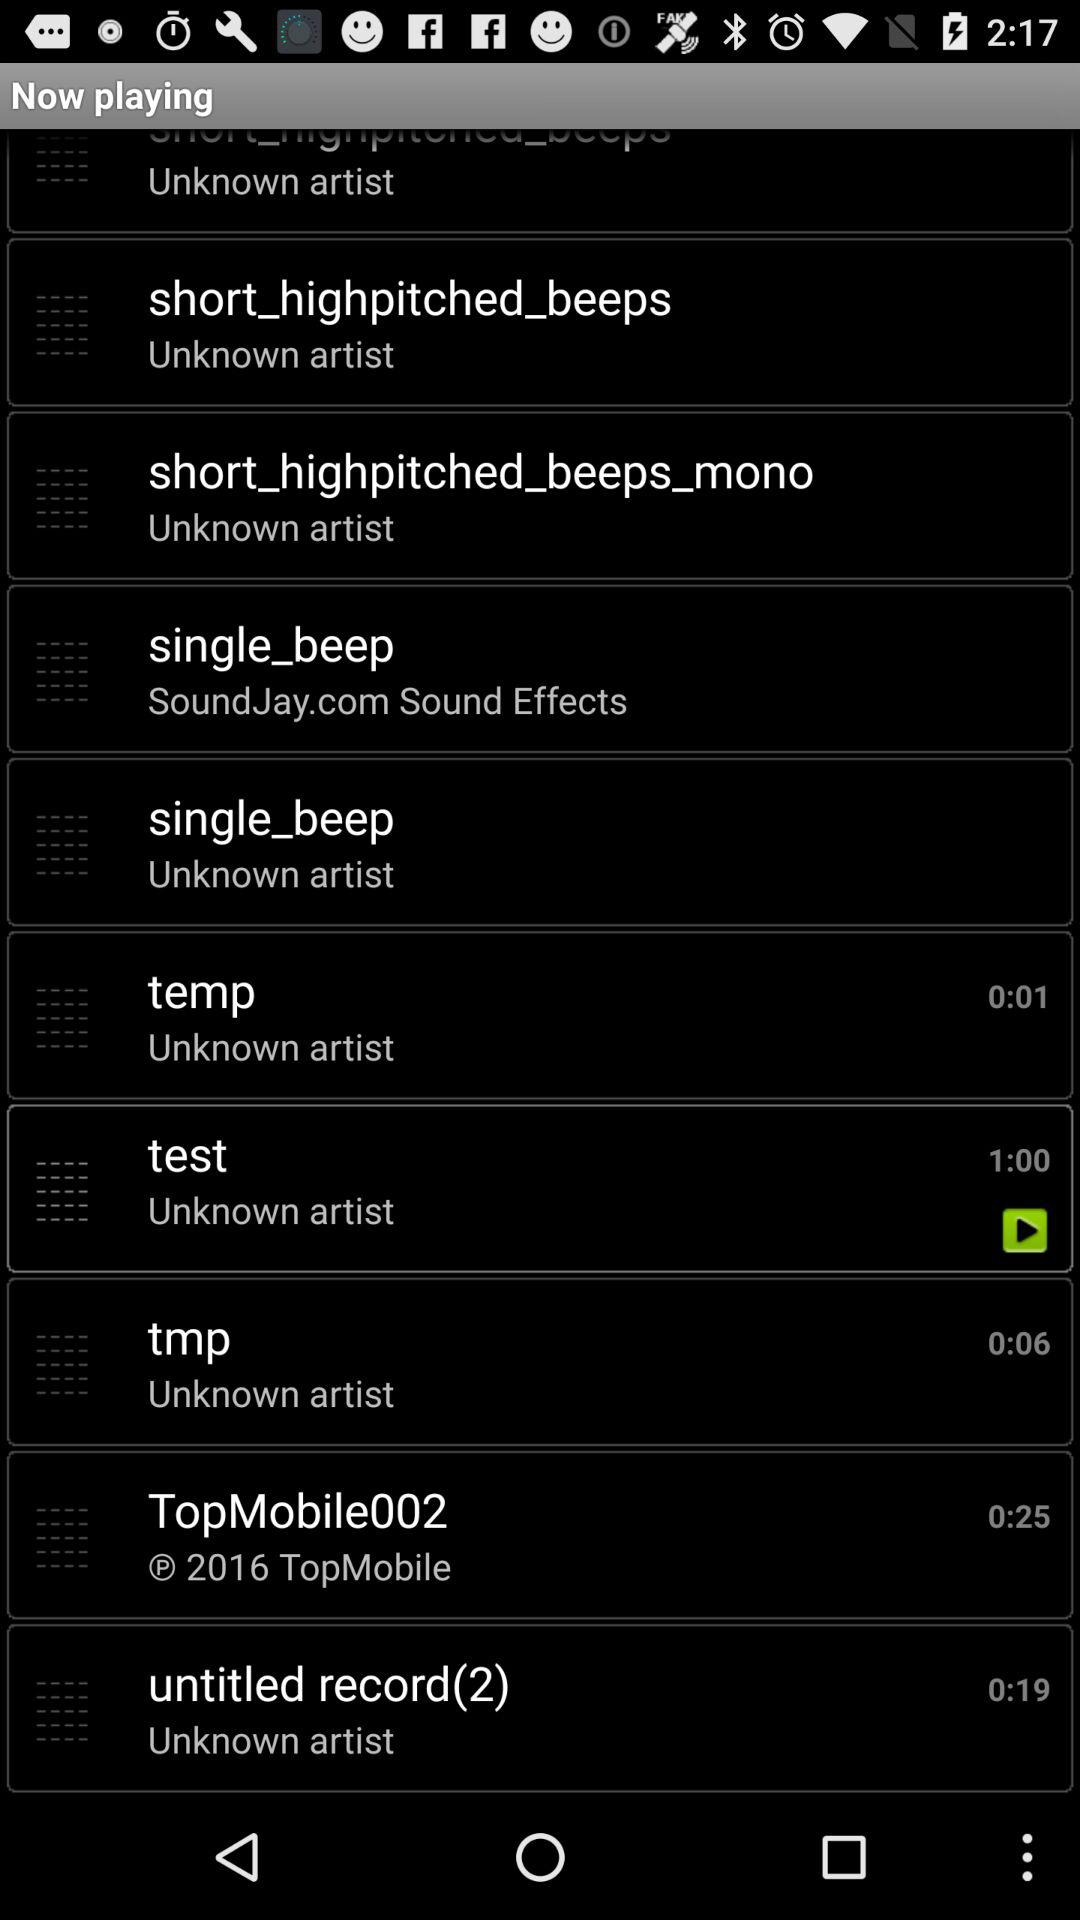How long is the duration of Topmobile002? The duration is 0:25. 